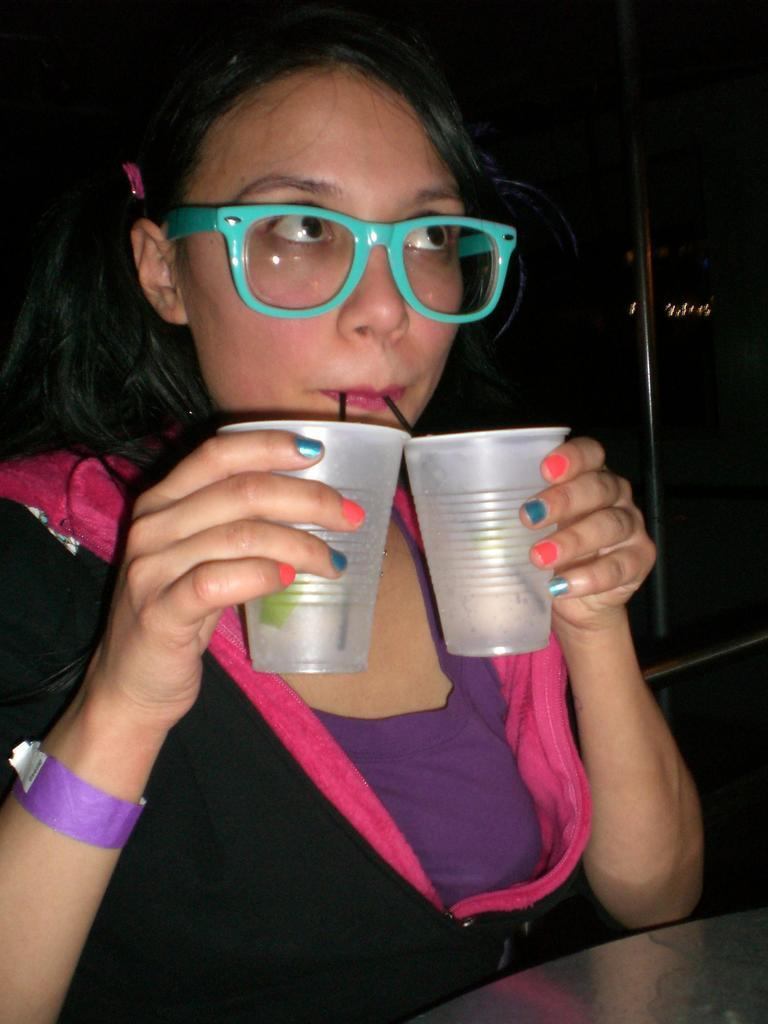Who is the main subject in the image? There is a girl in the image. What is the girl holding in her hands? The girl is holding two glasses in her hands. What is the girl doing with her mouth? The girl is placing two straws in her mouth. What is in front of the girl? There is a table in front of the girl. How would you describe the lighting in the image? The background of the image is dark. What type of meat is the girl preparing on the table in the image? There is no meat present in the image; the girl is holding glasses and placing straws in her mouth. 